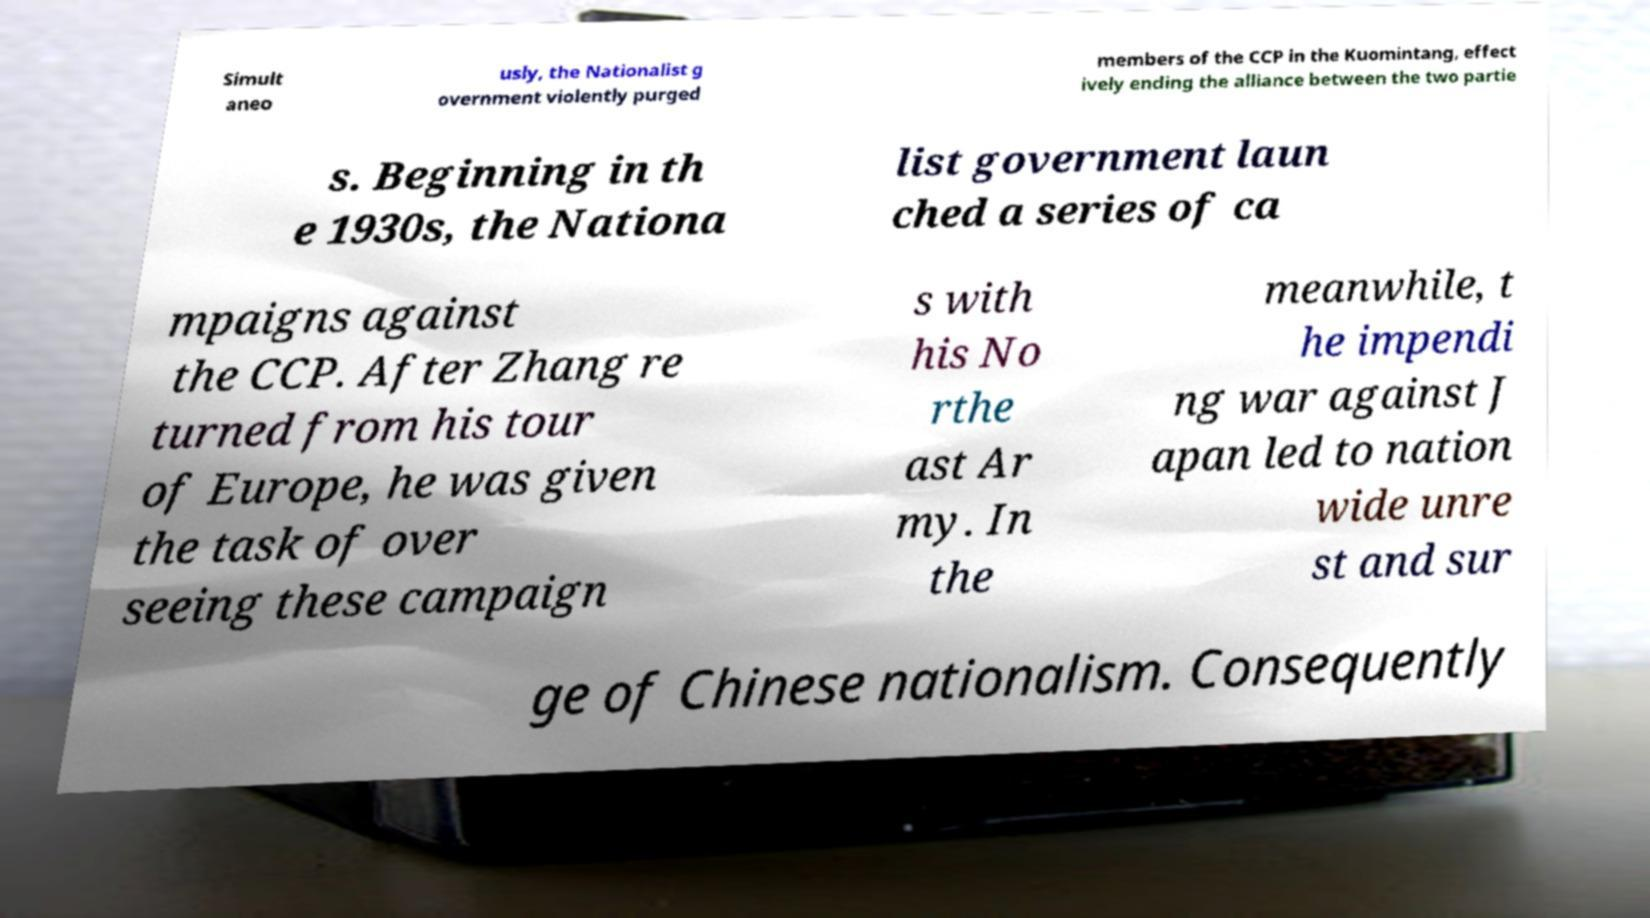Could you assist in decoding the text presented in this image and type it out clearly? Simult aneo usly, the Nationalist g overnment violently purged members of the CCP in the Kuomintang, effect ively ending the alliance between the two partie s. Beginning in th e 1930s, the Nationa list government laun ched a series of ca mpaigns against the CCP. After Zhang re turned from his tour of Europe, he was given the task of over seeing these campaign s with his No rthe ast Ar my. In the meanwhile, t he impendi ng war against J apan led to nation wide unre st and sur ge of Chinese nationalism. Consequently 